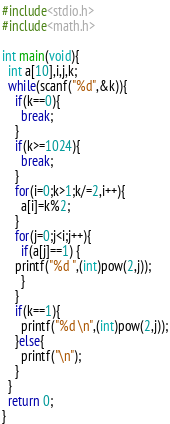<code> <loc_0><loc_0><loc_500><loc_500><_C_>#include<stdio.h>
#include<math.h>
 
int main(void){
  int a[10],i,j,k;
  while(scanf("%d",&k)){
    if(k==0){
      break;
    }
    if(k>=1024){
      break;
    }
    for(i=0;k>1;k/=2,i++){
      a[i]=k%2;
    }
    for(j=0;j<i;j++){
      if(a[j]==1) {
	printf("%d ",(int)pow(2,j));
      }
    }
    if(k==1){
      printf("%d \n",(int)pow(2,j));
    }else{
      printf("\n");
    }
  }
  return 0;
}</code> 